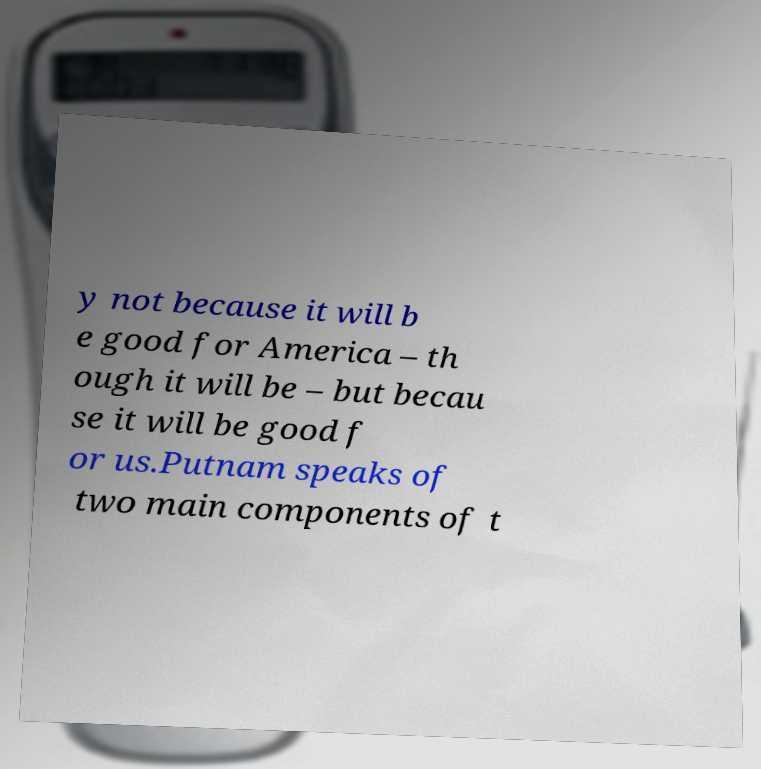Please read and relay the text visible in this image. What does it say? y not because it will b e good for America – th ough it will be – but becau se it will be good f or us.Putnam speaks of two main components of t 